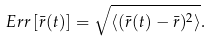<formula> <loc_0><loc_0><loc_500><loc_500>E r r \left [ \bar { r } ( t ) \right ] = \sqrt { \left < ( \bar { r } ( t ) - \bar { r } ) ^ { 2 } \right > } .</formula> 